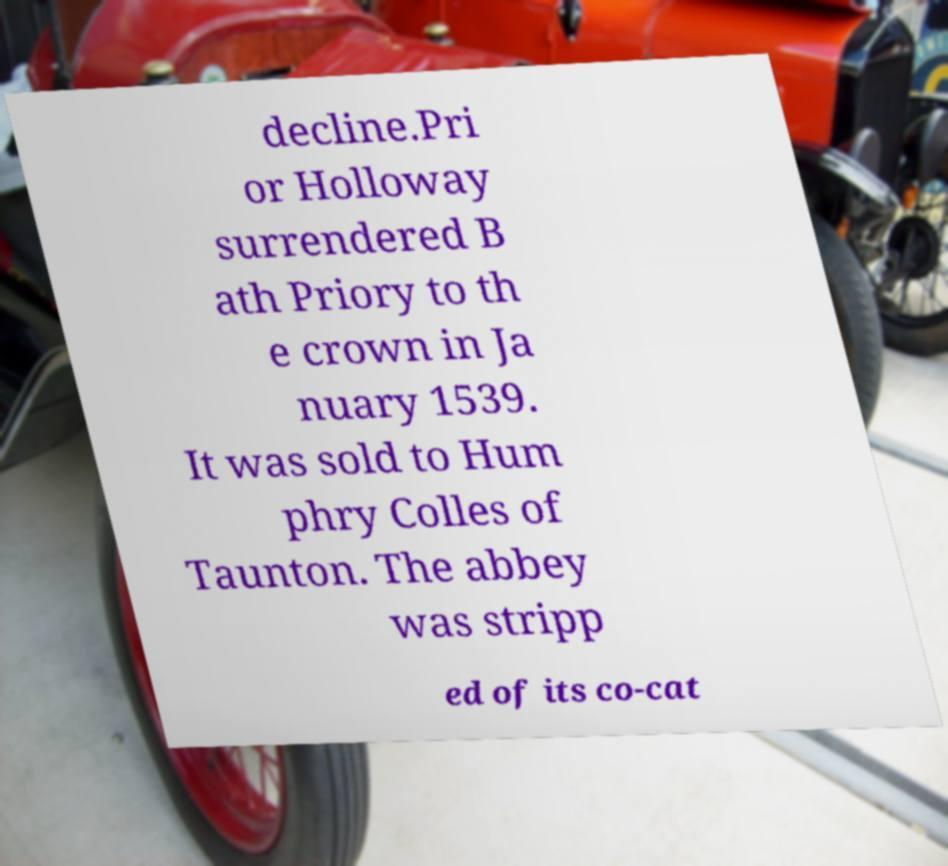What messages or text are displayed in this image? I need them in a readable, typed format. decline.Pri or Holloway surrendered B ath Priory to th e crown in Ja nuary 1539. It was sold to Hum phry Colles of Taunton. The abbey was stripp ed of its co-cat 